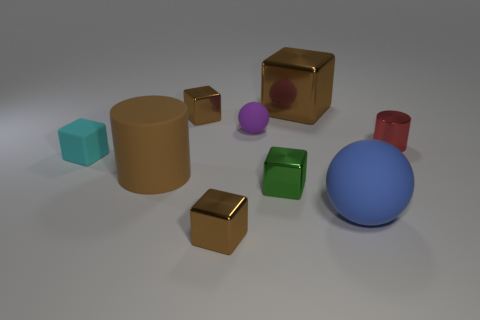Subtract all large metallic blocks. How many blocks are left? 4 Subtract all brown cylinders. How many cylinders are left? 1 Subtract 1 cylinders. How many cylinders are left? 1 Subtract all cylinders. How many objects are left? 7 Subtract all cyan spheres. How many yellow cylinders are left? 0 Subtract all green cubes. Subtract all big blue matte things. How many objects are left? 7 Add 7 small red cylinders. How many small red cylinders are left? 8 Add 2 blue balls. How many blue balls exist? 3 Subtract 0 blue cubes. How many objects are left? 9 Subtract all brown cylinders. Subtract all brown spheres. How many cylinders are left? 1 